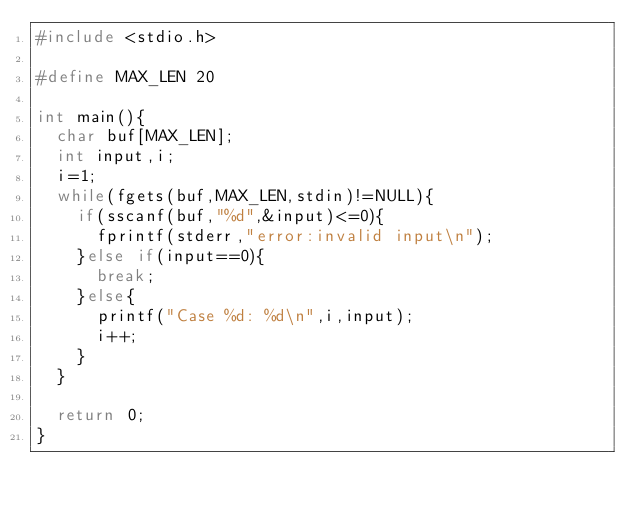Convert code to text. <code><loc_0><loc_0><loc_500><loc_500><_C_>#include <stdio.h>

#define MAX_LEN 20

int main(){
	char buf[MAX_LEN];
	int input,i;
	i=1;
	while(fgets(buf,MAX_LEN,stdin)!=NULL){
		if(sscanf(buf,"%d",&input)<=0){
			fprintf(stderr,"error:invalid input\n");
		}else if(input==0){
			break;
		}else{
			printf("Case %d: %d\n",i,input);
			i++;
		}
	}
	
	return 0;
}</code> 